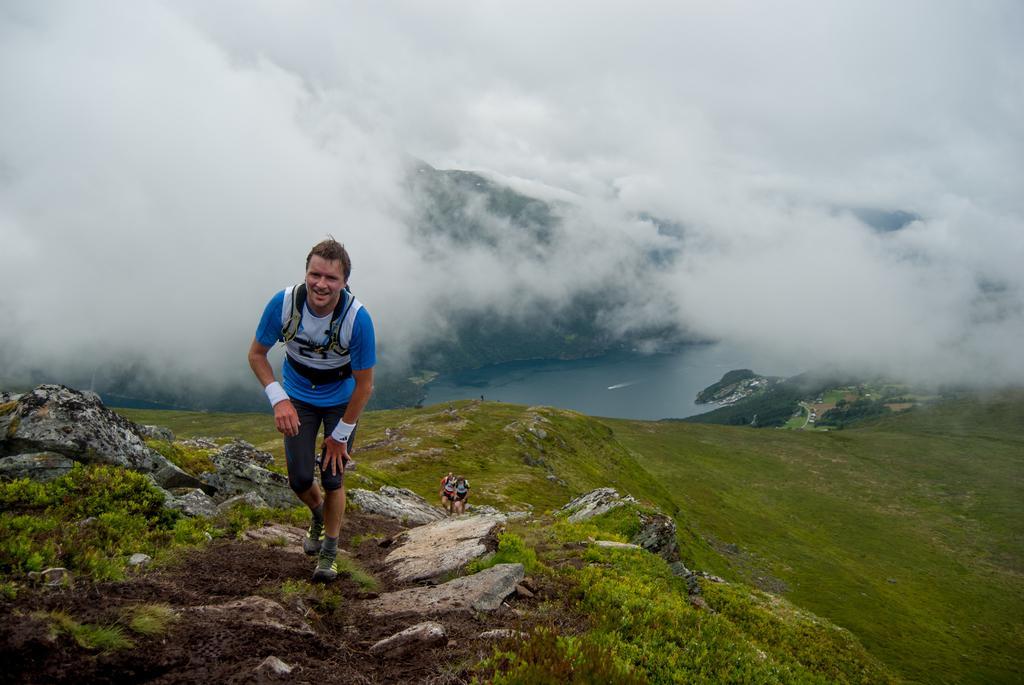How would you summarize this image in a sentence or two? In this picture I can observe some people in the middle of the picture. In the background I can observe river and some clouds in the sky. 